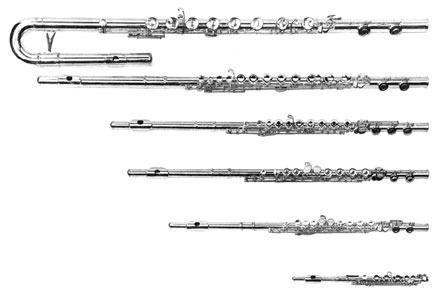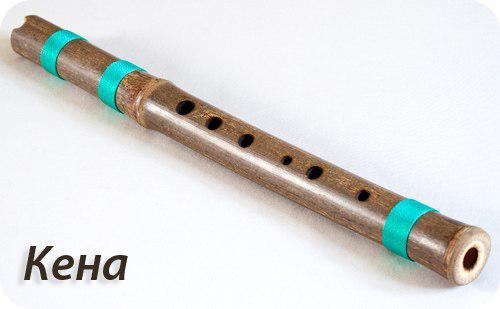The first image is the image on the left, the second image is the image on the right. Considering the images on both sides, is "There is a wood flute in the left image." valid? Answer yes or no. No. The first image is the image on the left, the second image is the image on the right. Evaluate the accuracy of this statement regarding the images: "The instrument in the image on the right has blue bands on it.". Is it true? Answer yes or no. Yes. 